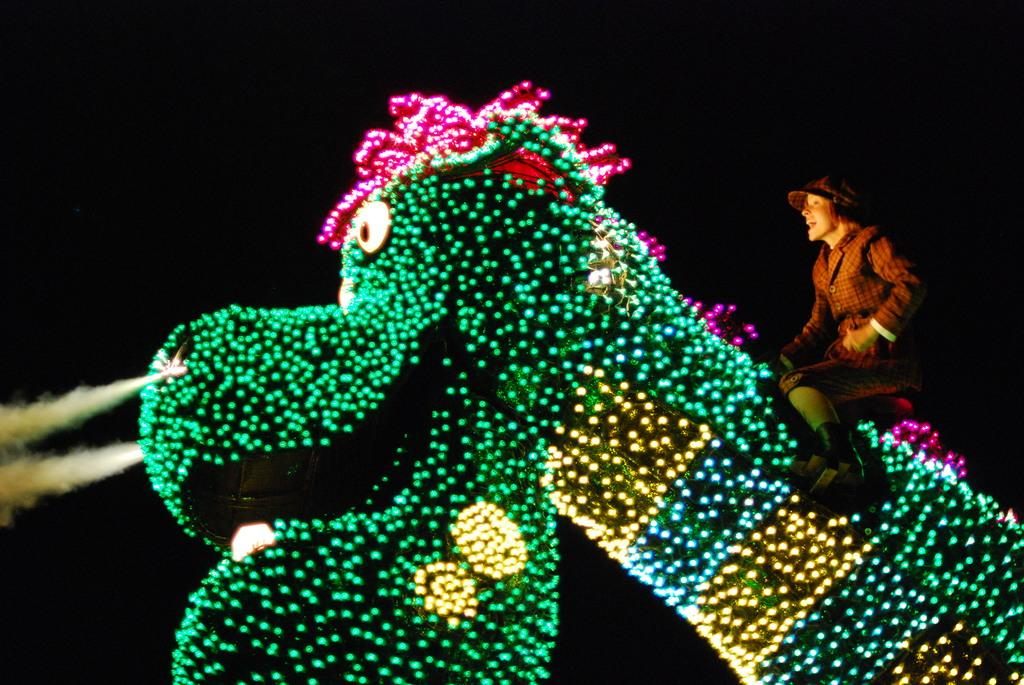What is the main subject of the picture? There is a dinosaur in the picture. What else can be seen in the picture besides the dinosaur? There is a man sitting in the picture, and he is wearing a shirt and a cap. Can you describe the lighting in the picture? There are lights arranged in the picture, and they are green in color. What is the color of the backdrop in the picture? The backdrop is dark. What type of silk fabric is draped over the dinosaur in the image? There is no silk fabric present in the image; it features a dinosaur, a man, and green lights. What is the voice of the dinosaur like in the image? There is no voice associated with the dinosaur in the image, as it is a static picture. 